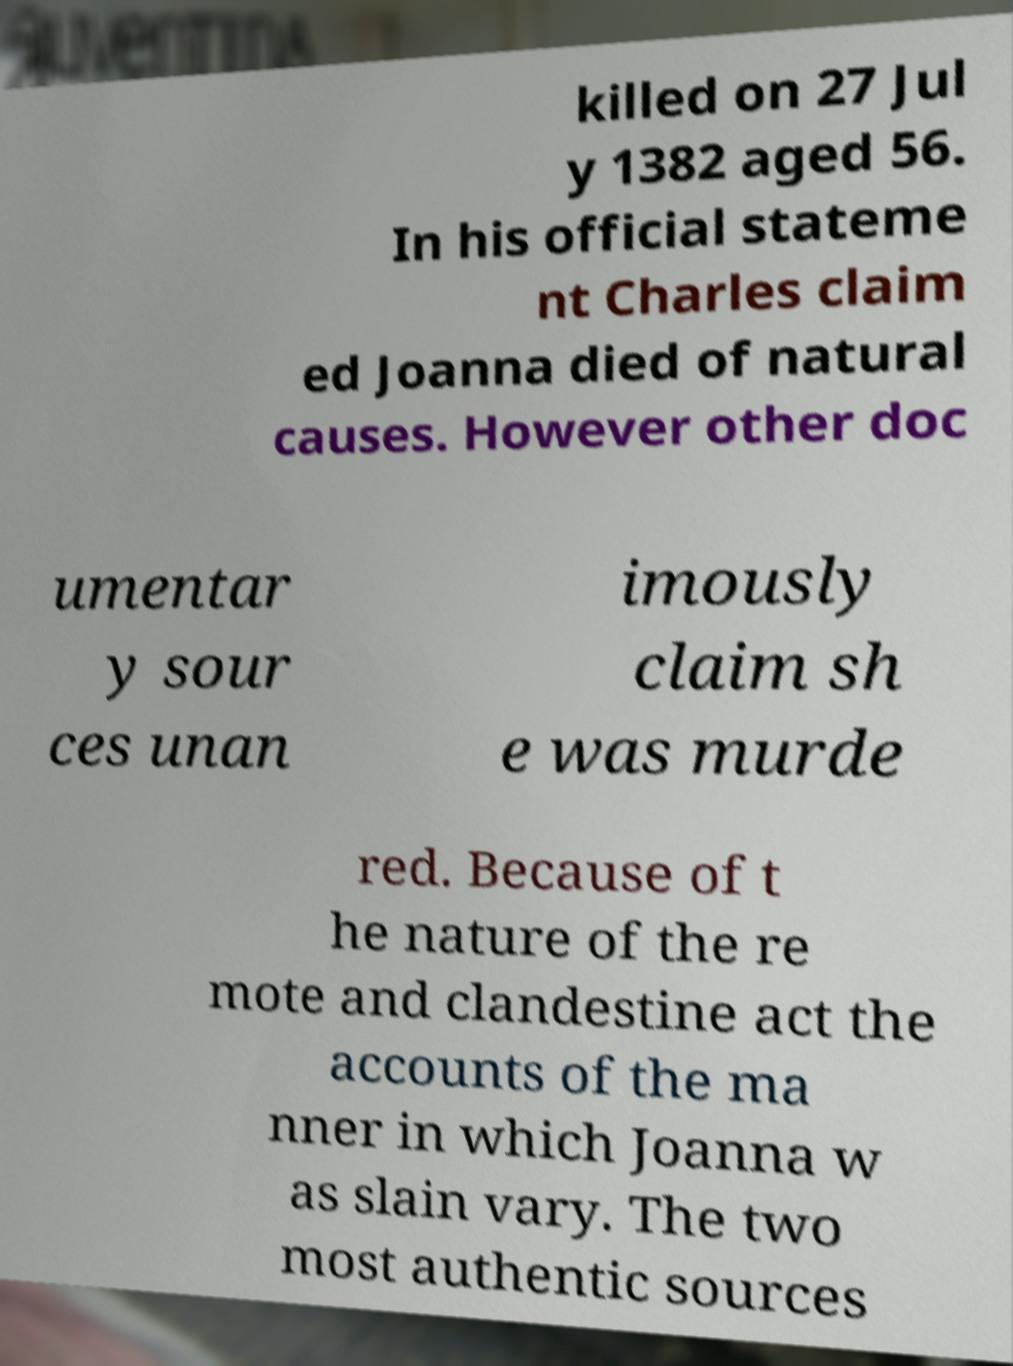Could you extract and type out the text from this image? killed on 27 Jul y 1382 aged 56. In his official stateme nt Charles claim ed Joanna died of natural causes. However other doc umentar y sour ces unan imously claim sh e was murde red. Because of t he nature of the re mote and clandestine act the accounts of the ma nner in which Joanna w as slain vary. The two most authentic sources 